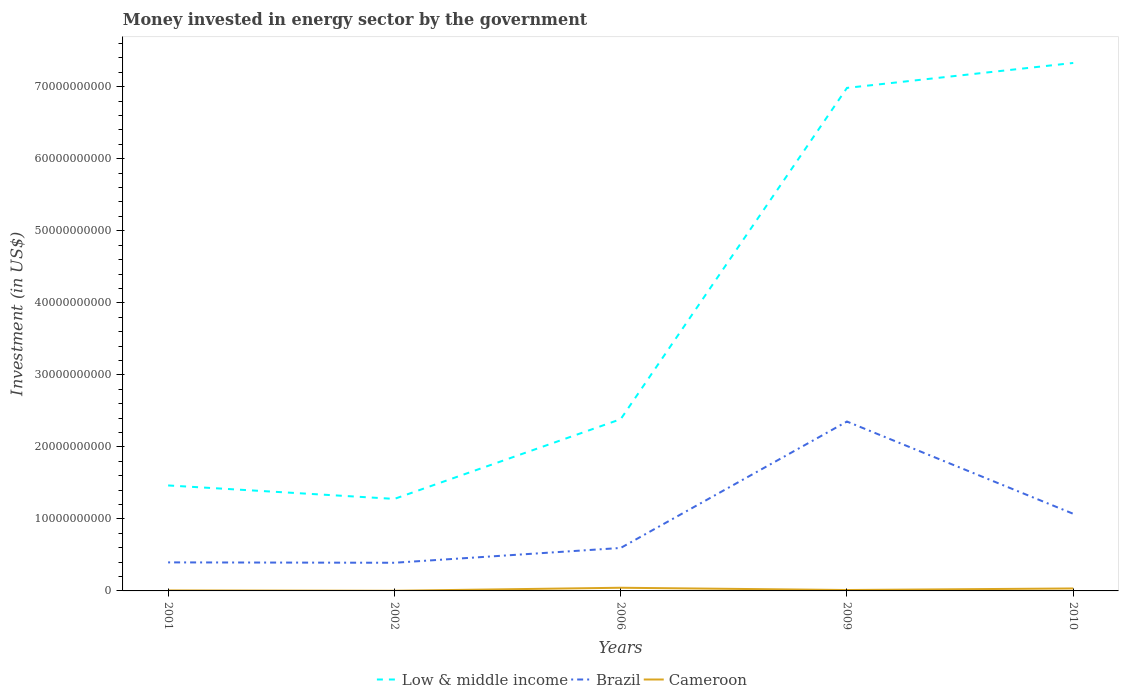How many different coloured lines are there?
Give a very brief answer. 3. Does the line corresponding to Low & middle income intersect with the line corresponding to Cameroon?
Offer a terse response. No. Across all years, what is the maximum money spent in energy sector in Brazil?
Offer a very short reply. 3.91e+09. What is the total money spent in energy sector in Brazil in the graph?
Give a very brief answer. -1.76e+1. What is the difference between the highest and the second highest money spent in energy sector in Brazil?
Your answer should be compact. 1.96e+1. What is the difference between the highest and the lowest money spent in energy sector in Low & middle income?
Give a very brief answer. 2. How many lines are there?
Offer a very short reply. 3. How many years are there in the graph?
Provide a succinct answer. 5. Does the graph contain any zero values?
Give a very brief answer. No. Does the graph contain grids?
Provide a short and direct response. No. How many legend labels are there?
Provide a succinct answer. 3. What is the title of the graph?
Your answer should be very brief. Money invested in energy sector by the government. Does "Central Europe" appear as one of the legend labels in the graph?
Provide a succinct answer. No. What is the label or title of the X-axis?
Your answer should be compact. Years. What is the label or title of the Y-axis?
Make the answer very short. Investment (in US$). What is the Investment (in US$) in Low & middle income in 2001?
Your response must be concise. 1.46e+1. What is the Investment (in US$) in Brazil in 2001?
Give a very brief answer. 3.96e+09. What is the Investment (in US$) of Cameroon in 2001?
Provide a succinct answer. 7.03e+07. What is the Investment (in US$) in Low & middle income in 2002?
Keep it short and to the point. 1.28e+1. What is the Investment (in US$) in Brazil in 2002?
Provide a short and direct response. 3.91e+09. What is the Investment (in US$) in Cameroon in 2002?
Your answer should be compact. 2.15e+07. What is the Investment (in US$) in Low & middle income in 2006?
Your answer should be compact. 2.38e+1. What is the Investment (in US$) in Brazil in 2006?
Your response must be concise. 5.97e+09. What is the Investment (in US$) in Cameroon in 2006?
Make the answer very short. 4.40e+08. What is the Investment (in US$) in Low & middle income in 2009?
Your answer should be compact. 6.98e+1. What is the Investment (in US$) of Brazil in 2009?
Offer a very short reply. 2.35e+1. What is the Investment (in US$) of Cameroon in 2009?
Your answer should be compact. 1.26e+08. What is the Investment (in US$) in Low & middle income in 2010?
Your response must be concise. 7.33e+1. What is the Investment (in US$) of Brazil in 2010?
Offer a terse response. 1.07e+1. What is the Investment (in US$) in Cameroon in 2010?
Make the answer very short. 3.42e+08. Across all years, what is the maximum Investment (in US$) in Low & middle income?
Your answer should be compact. 7.33e+1. Across all years, what is the maximum Investment (in US$) of Brazil?
Your response must be concise. 2.35e+1. Across all years, what is the maximum Investment (in US$) of Cameroon?
Your answer should be compact. 4.40e+08. Across all years, what is the minimum Investment (in US$) in Low & middle income?
Provide a short and direct response. 1.28e+1. Across all years, what is the minimum Investment (in US$) of Brazil?
Keep it short and to the point. 3.91e+09. Across all years, what is the minimum Investment (in US$) in Cameroon?
Provide a short and direct response. 2.15e+07. What is the total Investment (in US$) of Low & middle income in the graph?
Make the answer very short. 1.94e+11. What is the total Investment (in US$) in Brazil in the graph?
Your answer should be very brief. 4.81e+1. What is the total Investment (in US$) of Cameroon in the graph?
Your answer should be very brief. 1.00e+09. What is the difference between the Investment (in US$) of Low & middle income in 2001 and that in 2002?
Your response must be concise. 1.87e+09. What is the difference between the Investment (in US$) in Brazil in 2001 and that in 2002?
Keep it short and to the point. 5.20e+07. What is the difference between the Investment (in US$) in Cameroon in 2001 and that in 2002?
Offer a terse response. 4.88e+07. What is the difference between the Investment (in US$) in Low & middle income in 2001 and that in 2006?
Your answer should be compact. -9.20e+09. What is the difference between the Investment (in US$) of Brazil in 2001 and that in 2006?
Provide a succinct answer. -2.00e+09. What is the difference between the Investment (in US$) in Cameroon in 2001 and that in 2006?
Offer a terse response. -3.70e+08. What is the difference between the Investment (in US$) in Low & middle income in 2001 and that in 2009?
Ensure brevity in your answer.  -5.52e+1. What is the difference between the Investment (in US$) of Brazil in 2001 and that in 2009?
Your response must be concise. -1.96e+1. What is the difference between the Investment (in US$) in Cameroon in 2001 and that in 2009?
Offer a very short reply. -5.57e+07. What is the difference between the Investment (in US$) in Low & middle income in 2001 and that in 2010?
Keep it short and to the point. -5.87e+1. What is the difference between the Investment (in US$) of Brazil in 2001 and that in 2010?
Ensure brevity in your answer.  -6.75e+09. What is the difference between the Investment (in US$) of Cameroon in 2001 and that in 2010?
Offer a very short reply. -2.72e+08. What is the difference between the Investment (in US$) of Low & middle income in 2002 and that in 2006?
Provide a succinct answer. -1.11e+1. What is the difference between the Investment (in US$) of Brazil in 2002 and that in 2006?
Your answer should be very brief. -2.06e+09. What is the difference between the Investment (in US$) of Cameroon in 2002 and that in 2006?
Give a very brief answer. -4.18e+08. What is the difference between the Investment (in US$) in Low & middle income in 2002 and that in 2009?
Offer a terse response. -5.71e+1. What is the difference between the Investment (in US$) of Brazil in 2002 and that in 2009?
Offer a terse response. -1.96e+1. What is the difference between the Investment (in US$) of Cameroon in 2002 and that in 2009?
Give a very brief answer. -1.04e+08. What is the difference between the Investment (in US$) in Low & middle income in 2002 and that in 2010?
Offer a terse response. -6.05e+1. What is the difference between the Investment (in US$) of Brazil in 2002 and that in 2010?
Keep it short and to the point. -6.80e+09. What is the difference between the Investment (in US$) of Cameroon in 2002 and that in 2010?
Your answer should be compact. -3.20e+08. What is the difference between the Investment (in US$) of Low & middle income in 2006 and that in 2009?
Provide a succinct answer. -4.60e+1. What is the difference between the Investment (in US$) of Brazil in 2006 and that in 2009?
Your response must be concise. -1.76e+1. What is the difference between the Investment (in US$) in Cameroon in 2006 and that in 2009?
Give a very brief answer. 3.14e+08. What is the difference between the Investment (in US$) of Low & middle income in 2006 and that in 2010?
Offer a very short reply. -4.95e+1. What is the difference between the Investment (in US$) in Brazil in 2006 and that in 2010?
Your answer should be compact. -4.74e+09. What is the difference between the Investment (in US$) of Cameroon in 2006 and that in 2010?
Provide a short and direct response. 9.80e+07. What is the difference between the Investment (in US$) in Low & middle income in 2009 and that in 2010?
Offer a terse response. -3.46e+09. What is the difference between the Investment (in US$) in Brazil in 2009 and that in 2010?
Your answer should be very brief. 1.28e+1. What is the difference between the Investment (in US$) of Cameroon in 2009 and that in 2010?
Offer a terse response. -2.16e+08. What is the difference between the Investment (in US$) in Low & middle income in 2001 and the Investment (in US$) in Brazil in 2002?
Your response must be concise. 1.07e+1. What is the difference between the Investment (in US$) in Low & middle income in 2001 and the Investment (in US$) in Cameroon in 2002?
Provide a short and direct response. 1.46e+1. What is the difference between the Investment (in US$) in Brazil in 2001 and the Investment (in US$) in Cameroon in 2002?
Your answer should be compact. 3.94e+09. What is the difference between the Investment (in US$) of Low & middle income in 2001 and the Investment (in US$) of Brazil in 2006?
Provide a short and direct response. 8.68e+09. What is the difference between the Investment (in US$) of Low & middle income in 2001 and the Investment (in US$) of Cameroon in 2006?
Your answer should be compact. 1.42e+1. What is the difference between the Investment (in US$) of Brazil in 2001 and the Investment (in US$) of Cameroon in 2006?
Your answer should be very brief. 3.52e+09. What is the difference between the Investment (in US$) of Low & middle income in 2001 and the Investment (in US$) of Brazil in 2009?
Your answer should be compact. -8.87e+09. What is the difference between the Investment (in US$) of Low & middle income in 2001 and the Investment (in US$) of Cameroon in 2009?
Keep it short and to the point. 1.45e+1. What is the difference between the Investment (in US$) of Brazil in 2001 and the Investment (in US$) of Cameroon in 2009?
Provide a succinct answer. 3.84e+09. What is the difference between the Investment (in US$) of Low & middle income in 2001 and the Investment (in US$) of Brazil in 2010?
Offer a terse response. 3.94e+09. What is the difference between the Investment (in US$) in Low & middle income in 2001 and the Investment (in US$) in Cameroon in 2010?
Keep it short and to the point. 1.43e+1. What is the difference between the Investment (in US$) of Brazil in 2001 and the Investment (in US$) of Cameroon in 2010?
Give a very brief answer. 3.62e+09. What is the difference between the Investment (in US$) in Low & middle income in 2002 and the Investment (in US$) in Brazil in 2006?
Your response must be concise. 6.81e+09. What is the difference between the Investment (in US$) of Low & middle income in 2002 and the Investment (in US$) of Cameroon in 2006?
Keep it short and to the point. 1.23e+1. What is the difference between the Investment (in US$) of Brazil in 2002 and the Investment (in US$) of Cameroon in 2006?
Make the answer very short. 3.47e+09. What is the difference between the Investment (in US$) in Low & middle income in 2002 and the Investment (in US$) in Brazil in 2009?
Offer a terse response. -1.07e+1. What is the difference between the Investment (in US$) of Low & middle income in 2002 and the Investment (in US$) of Cameroon in 2009?
Your answer should be compact. 1.27e+1. What is the difference between the Investment (in US$) in Brazil in 2002 and the Investment (in US$) in Cameroon in 2009?
Your response must be concise. 3.78e+09. What is the difference between the Investment (in US$) in Low & middle income in 2002 and the Investment (in US$) in Brazil in 2010?
Give a very brief answer. 2.07e+09. What is the difference between the Investment (in US$) in Low & middle income in 2002 and the Investment (in US$) in Cameroon in 2010?
Give a very brief answer. 1.24e+1. What is the difference between the Investment (in US$) in Brazil in 2002 and the Investment (in US$) in Cameroon in 2010?
Your answer should be very brief. 3.57e+09. What is the difference between the Investment (in US$) in Low & middle income in 2006 and the Investment (in US$) in Brazil in 2009?
Offer a very short reply. 3.27e+08. What is the difference between the Investment (in US$) in Low & middle income in 2006 and the Investment (in US$) in Cameroon in 2009?
Keep it short and to the point. 2.37e+1. What is the difference between the Investment (in US$) in Brazil in 2006 and the Investment (in US$) in Cameroon in 2009?
Offer a very short reply. 5.84e+09. What is the difference between the Investment (in US$) in Low & middle income in 2006 and the Investment (in US$) in Brazil in 2010?
Keep it short and to the point. 1.31e+1. What is the difference between the Investment (in US$) of Low & middle income in 2006 and the Investment (in US$) of Cameroon in 2010?
Ensure brevity in your answer.  2.35e+1. What is the difference between the Investment (in US$) in Brazil in 2006 and the Investment (in US$) in Cameroon in 2010?
Your answer should be compact. 5.62e+09. What is the difference between the Investment (in US$) of Low & middle income in 2009 and the Investment (in US$) of Brazil in 2010?
Your response must be concise. 5.91e+1. What is the difference between the Investment (in US$) in Low & middle income in 2009 and the Investment (in US$) in Cameroon in 2010?
Keep it short and to the point. 6.95e+1. What is the difference between the Investment (in US$) of Brazil in 2009 and the Investment (in US$) of Cameroon in 2010?
Offer a very short reply. 2.32e+1. What is the average Investment (in US$) of Low & middle income per year?
Offer a terse response. 3.89e+1. What is the average Investment (in US$) of Brazil per year?
Give a very brief answer. 9.61e+09. What is the average Investment (in US$) of Cameroon per year?
Offer a terse response. 2.00e+08. In the year 2001, what is the difference between the Investment (in US$) in Low & middle income and Investment (in US$) in Brazil?
Your response must be concise. 1.07e+1. In the year 2001, what is the difference between the Investment (in US$) in Low & middle income and Investment (in US$) in Cameroon?
Make the answer very short. 1.46e+1. In the year 2001, what is the difference between the Investment (in US$) in Brazil and Investment (in US$) in Cameroon?
Give a very brief answer. 3.89e+09. In the year 2002, what is the difference between the Investment (in US$) in Low & middle income and Investment (in US$) in Brazil?
Offer a very short reply. 8.87e+09. In the year 2002, what is the difference between the Investment (in US$) of Low & middle income and Investment (in US$) of Cameroon?
Keep it short and to the point. 1.28e+1. In the year 2002, what is the difference between the Investment (in US$) in Brazil and Investment (in US$) in Cameroon?
Your response must be concise. 3.89e+09. In the year 2006, what is the difference between the Investment (in US$) in Low & middle income and Investment (in US$) in Brazil?
Ensure brevity in your answer.  1.79e+1. In the year 2006, what is the difference between the Investment (in US$) of Low & middle income and Investment (in US$) of Cameroon?
Your answer should be compact. 2.34e+1. In the year 2006, what is the difference between the Investment (in US$) in Brazil and Investment (in US$) in Cameroon?
Your answer should be compact. 5.53e+09. In the year 2009, what is the difference between the Investment (in US$) in Low & middle income and Investment (in US$) in Brazil?
Keep it short and to the point. 4.63e+1. In the year 2009, what is the difference between the Investment (in US$) of Low & middle income and Investment (in US$) of Cameroon?
Your answer should be compact. 6.97e+1. In the year 2009, what is the difference between the Investment (in US$) of Brazil and Investment (in US$) of Cameroon?
Give a very brief answer. 2.34e+1. In the year 2010, what is the difference between the Investment (in US$) of Low & middle income and Investment (in US$) of Brazil?
Your answer should be very brief. 6.26e+1. In the year 2010, what is the difference between the Investment (in US$) of Low & middle income and Investment (in US$) of Cameroon?
Keep it short and to the point. 7.30e+1. In the year 2010, what is the difference between the Investment (in US$) in Brazil and Investment (in US$) in Cameroon?
Make the answer very short. 1.04e+1. What is the ratio of the Investment (in US$) in Low & middle income in 2001 to that in 2002?
Make the answer very short. 1.15. What is the ratio of the Investment (in US$) in Brazil in 2001 to that in 2002?
Your response must be concise. 1.01. What is the ratio of the Investment (in US$) in Cameroon in 2001 to that in 2002?
Your response must be concise. 3.27. What is the ratio of the Investment (in US$) of Low & middle income in 2001 to that in 2006?
Keep it short and to the point. 0.61. What is the ratio of the Investment (in US$) of Brazil in 2001 to that in 2006?
Make the answer very short. 0.66. What is the ratio of the Investment (in US$) in Cameroon in 2001 to that in 2006?
Keep it short and to the point. 0.16. What is the ratio of the Investment (in US$) in Low & middle income in 2001 to that in 2009?
Your answer should be compact. 0.21. What is the ratio of the Investment (in US$) of Brazil in 2001 to that in 2009?
Provide a succinct answer. 0.17. What is the ratio of the Investment (in US$) of Cameroon in 2001 to that in 2009?
Your response must be concise. 0.56. What is the ratio of the Investment (in US$) of Low & middle income in 2001 to that in 2010?
Offer a terse response. 0.2. What is the ratio of the Investment (in US$) in Brazil in 2001 to that in 2010?
Provide a succinct answer. 0.37. What is the ratio of the Investment (in US$) of Cameroon in 2001 to that in 2010?
Offer a terse response. 0.21. What is the ratio of the Investment (in US$) of Low & middle income in 2002 to that in 2006?
Offer a terse response. 0.54. What is the ratio of the Investment (in US$) in Brazil in 2002 to that in 2006?
Offer a very short reply. 0.66. What is the ratio of the Investment (in US$) of Cameroon in 2002 to that in 2006?
Give a very brief answer. 0.05. What is the ratio of the Investment (in US$) of Low & middle income in 2002 to that in 2009?
Offer a terse response. 0.18. What is the ratio of the Investment (in US$) in Brazil in 2002 to that in 2009?
Offer a very short reply. 0.17. What is the ratio of the Investment (in US$) in Cameroon in 2002 to that in 2009?
Offer a very short reply. 0.17. What is the ratio of the Investment (in US$) of Low & middle income in 2002 to that in 2010?
Give a very brief answer. 0.17. What is the ratio of the Investment (in US$) in Brazil in 2002 to that in 2010?
Provide a succinct answer. 0.37. What is the ratio of the Investment (in US$) of Cameroon in 2002 to that in 2010?
Keep it short and to the point. 0.06. What is the ratio of the Investment (in US$) of Low & middle income in 2006 to that in 2009?
Your response must be concise. 0.34. What is the ratio of the Investment (in US$) in Brazil in 2006 to that in 2009?
Offer a very short reply. 0.25. What is the ratio of the Investment (in US$) of Cameroon in 2006 to that in 2009?
Your response must be concise. 3.49. What is the ratio of the Investment (in US$) in Low & middle income in 2006 to that in 2010?
Your response must be concise. 0.33. What is the ratio of the Investment (in US$) in Brazil in 2006 to that in 2010?
Your response must be concise. 0.56. What is the ratio of the Investment (in US$) in Cameroon in 2006 to that in 2010?
Ensure brevity in your answer.  1.29. What is the ratio of the Investment (in US$) in Low & middle income in 2009 to that in 2010?
Keep it short and to the point. 0.95. What is the ratio of the Investment (in US$) of Brazil in 2009 to that in 2010?
Offer a terse response. 2.2. What is the ratio of the Investment (in US$) in Cameroon in 2009 to that in 2010?
Your response must be concise. 0.37. What is the difference between the highest and the second highest Investment (in US$) of Low & middle income?
Make the answer very short. 3.46e+09. What is the difference between the highest and the second highest Investment (in US$) of Brazil?
Give a very brief answer. 1.28e+1. What is the difference between the highest and the second highest Investment (in US$) of Cameroon?
Your answer should be very brief. 9.80e+07. What is the difference between the highest and the lowest Investment (in US$) of Low & middle income?
Make the answer very short. 6.05e+1. What is the difference between the highest and the lowest Investment (in US$) of Brazil?
Your answer should be compact. 1.96e+1. What is the difference between the highest and the lowest Investment (in US$) of Cameroon?
Offer a very short reply. 4.18e+08. 